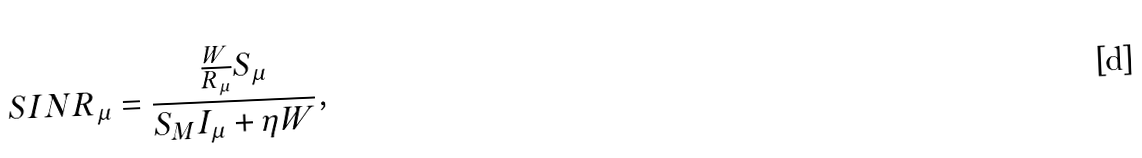Convert formula to latex. <formula><loc_0><loc_0><loc_500><loc_500>S I N R _ { \mu } = \frac { \frac { W } { R _ { \mu } } S _ { \mu } } { S _ { M } I _ { \mu } + \eta W } ,</formula> 